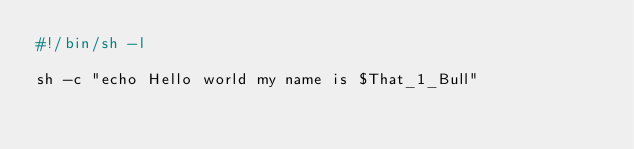<code> <loc_0><loc_0><loc_500><loc_500><_Bash_>#!/bin/sh -l

sh -c "echo Hello world my name is $That_1_Bull"
</code> 